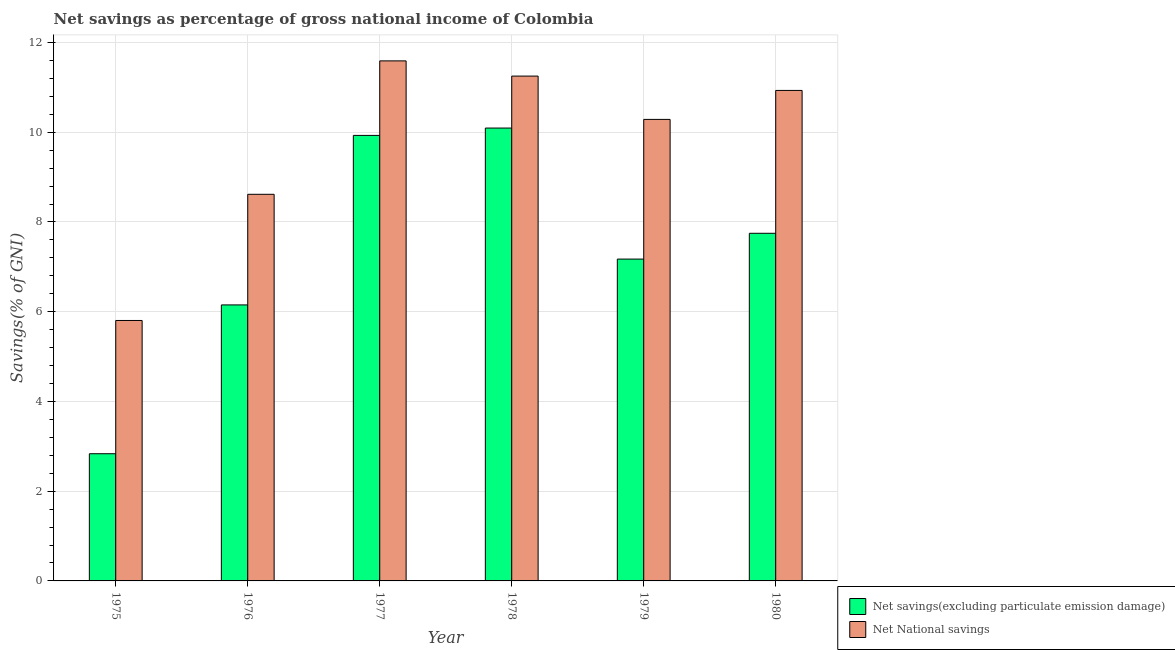How many groups of bars are there?
Your answer should be compact. 6. Are the number of bars per tick equal to the number of legend labels?
Make the answer very short. Yes. What is the label of the 6th group of bars from the left?
Keep it short and to the point. 1980. What is the net national savings in 1977?
Your answer should be compact. 11.59. Across all years, what is the maximum net national savings?
Your answer should be very brief. 11.59. Across all years, what is the minimum net national savings?
Provide a short and direct response. 5.8. In which year was the net savings(excluding particulate emission damage) maximum?
Provide a succinct answer. 1978. In which year was the net savings(excluding particulate emission damage) minimum?
Make the answer very short. 1975. What is the total net savings(excluding particulate emission damage) in the graph?
Keep it short and to the point. 43.93. What is the difference between the net national savings in 1976 and that in 1977?
Keep it short and to the point. -2.97. What is the difference between the net savings(excluding particulate emission damage) in 1980 and the net national savings in 1977?
Your answer should be compact. -2.18. What is the average net national savings per year?
Give a very brief answer. 9.75. In how many years, is the net savings(excluding particulate emission damage) greater than 9.2 %?
Keep it short and to the point. 2. What is the ratio of the net savings(excluding particulate emission damage) in 1975 to that in 1977?
Keep it short and to the point. 0.29. Is the net savings(excluding particulate emission damage) in 1975 less than that in 1978?
Your answer should be very brief. Yes. Is the difference between the net national savings in 1977 and 1980 greater than the difference between the net savings(excluding particulate emission damage) in 1977 and 1980?
Your answer should be compact. No. What is the difference between the highest and the second highest net savings(excluding particulate emission damage)?
Ensure brevity in your answer.  0.16. What is the difference between the highest and the lowest net national savings?
Offer a terse response. 5.79. In how many years, is the net savings(excluding particulate emission damage) greater than the average net savings(excluding particulate emission damage) taken over all years?
Provide a succinct answer. 3. What does the 1st bar from the left in 1976 represents?
Provide a short and direct response. Net savings(excluding particulate emission damage). What does the 2nd bar from the right in 1979 represents?
Offer a terse response. Net savings(excluding particulate emission damage). What is the difference between two consecutive major ticks on the Y-axis?
Offer a terse response. 2. How many legend labels are there?
Provide a short and direct response. 2. What is the title of the graph?
Your response must be concise. Net savings as percentage of gross national income of Colombia. What is the label or title of the X-axis?
Ensure brevity in your answer.  Year. What is the label or title of the Y-axis?
Make the answer very short. Savings(% of GNI). What is the Savings(% of GNI) in Net savings(excluding particulate emission damage) in 1975?
Ensure brevity in your answer.  2.84. What is the Savings(% of GNI) of Net National savings in 1975?
Provide a succinct answer. 5.8. What is the Savings(% of GNI) of Net savings(excluding particulate emission damage) in 1976?
Keep it short and to the point. 6.15. What is the Savings(% of GNI) of Net National savings in 1976?
Provide a succinct answer. 8.62. What is the Savings(% of GNI) in Net savings(excluding particulate emission damage) in 1977?
Your response must be concise. 9.93. What is the Savings(% of GNI) of Net National savings in 1977?
Provide a succinct answer. 11.59. What is the Savings(% of GNI) of Net savings(excluding particulate emission damage) in 1978?
Provide a short and direct response. 10.09. What is the Savings(% of GNI) of Net National savings in 1978?
Your answer should be compact. 11.25. What is the Savings(% of GNI) of Net savings(excluding particulate emission damage) in 1979?
Provide a succinct answer. 7.17. What is the Savings(% of GNI) in Net National savings in 1979?
Your answer should be compact. 10.29. What is the Savings(% of GNI) in Net savings(excluding particulate emission damage) in 1980?
Offer a very short reply. 7.75. What is the Savings(% of GNI) in Net National savings in 1980?
Your answer should be very brief. 10.93. Across all years, what is the maximum Savings(% of GNI) of Net savings(excluding particulate emission damage)?
Your response must be concise. 10.09. Across all years, what is the maximum Savings(% of GNI) in Net National savings?
Make the answer very short. 11.59. Across all years, what is the minimum Savings(% of GNI) in Net savings(excluding particulate emission damage)?
Offer a terse response. 2.84. Across all years, what is the minimum Savings(% of GNI) of Net National savings?
Your response must be concise. 5.8. What is the total Savings(% of GNI) of Net savings(excluding particulate emission damage) in the graph?
Make the answer very short. 43.93. What is the total Savings(% of GNI) in Net National savings in the graph?
Ensure brevity in your answer.  58.48. What is the difference between the Savings(% of GNI) of Net savings(excluding particulate emission damage) in 1975 and that in 1976?
Make the answer very short. -3.32. What is the difference between the Savings(% of GNI) of Net National savings in 1975 and that in 1976?
Ensure brevity in your answer.  -2.81. What is the difference between the Savings(% of GNI) in Net savings(excluding particulate emission damage) in 1975 and that in 1977?
Provide a short and direct response. -7.09. What is the difference between the Savings(% of GNI) of Net National savings in 1975 and that in 1977?
Keep it short and to the point. -5.79. What is the difference between the Savings(% of GNI) in Net savings(excluding particulate emission damage) in 1975 and that in 1978?
Offer a very short reply. -7.26. What is the difference between the Savings(% of GNI) in Net National savings in 1975 and that in 1978?
Provide a short and direct response. -5.45. What is the difference between the Savings(% of GNI) in Net savings(excluding particulate emission damage) in 1975 and that in 1979?
Provide a short and direct response. -4.34. What is the difference between the Savings(% of GNI) in Net National savings in 1975 and that in 1979?
Offer a very short reply. -4.48. What is the difference between the Savings(% of GNI) of Net savings(excluding particulate emission damage) in 1975 and that in 1980?
Offer a terse response. -4.91. What is the difference between the Savings(% of GNI) in Net National savings in 1975 and that in 1980?
Offer a very short reply. -5.13. What is the difference between the Savings(% of GNI) in Net savings(excluding particulate emission damage) in 1976 and that in 1977?
Offer a very short reply. -3.78. What is the difference between the Savings(% of GNI) in Net National savings in 1976 and that in 1977?
Your answer should be very brief. -2.97. What is the difference between the Savings(% of GNI) of Net savings(excluding particulate emission damage) in 1976 and that in 1978?
Provide a succinct answer. -3.94. What is the difference between the Savings(% of GNI) of Net National savings in 1976 and that in 1978?
Your answer should be compact. -2.63. What is the difference between the Savings(% of GNI) in Net savings(excluding particulate emission damage) in 1976 and that in 1979?
Ensure brevity in your answer.  -1.02. What is the difference between the Savings(% of GNI) in Net National savings in 1976 and that in 1979?
Make the answer very short. -1.67. What is the difference between the Savings(% of GNI) of Net savings(excluding particulate emission damage) in 1976 and that in 1980?
Offer a very short reply. -1.6. What is the difference between the Savings(% of GNI) of Net National savings in 1976 and that in 1980?
Your answer should be compact. -2.31. What is the difference between the Savings(% of GNI) of Net savings(excluding particulate emission damage) in 1977 and that in 1978?
Offer a terse response. -0.16. What is the difference between the Savings(% of GNI) of Net National savings in 1977 and that in 1978?
Your response must be concise. 0.34. What is the difference between the Savings(% of GNI) in Net savings(excluding particulate emission damage) in 1977 and that in 1979?
Provide a short and direct response. 2.76. What is the difference between the Savings(% of GNI) in Net National savings in 1977 and that in 1979?
Offer a terse response. 1.3. What is the difference between the Savings(% of GNI) in Net savings(excluding particulate emission damage) in 1977 and that in 1980?
Your answer should be very brief. 2.18. What is the difference between the Savings(% of GNI) in Net National savings in 1977 and that in 1980?
Provide a short and direct response. 0.66. What is the difference between the Savings(% of GNI) in Net savings(excluding particulate emission damage) in 1978 and that in 1979?
Your answer should be compact. 2.92. What is the difference between the Savings(% of GNI) of Net National savings in 1978 and that in 1979?
Make the answer very short. 0.97. What is the difference between the Savings(% of GNI) of Net savings(excluding particulate emission damage) in 1978 and that in 1980?
Make the answer very short. 2.35. What is the difference between the Savings(% of GNI) in Net National savings in 1978 and that in 1980?
Ensure brevity in your answer.  0.32. What is the difference between the Savings(% of GNI) of Net savings(excluding particulate emission damage) in 1979 and that in 1980?
Your answer should be compact. -0.57. What is the difference between the Savings(% of GNI) of Net National savings in 1979 and that in 1980?
Offer a terse response. -0.65. What is the difference between the Savings(% of GNI) of Net savings(excluding particulate emission damage) in 1975 and the Savings(% of GNI) of Net National savings in 1976?
Offer a terse response. -5.78. What is the difference between the Savings(% of GNI) of Net savings(excluding particulate emission damage) in 1975 and the Savings(% of GNI) of Net National savings in 1977?
Your response must be concise. -8.76. What is the difference between the Savings(% of GNI) of Net savings(excluding particulate emission damage) in 1975 and the Savings(% of GNI) of Net National savings in 1978?
Offer a terse response. -8.42. What is the difference between the Savings(% of GNI) of Net savings(excluding particulate emission damage) in 1975 and the Savings(% of GNI) of Net National savings in 1979?
Keep it short and to the point. -7.45. What is the difference between the Savings(% of GNI) in Net savings(excluding particulate emission damage) in 1975 and the Savings(% of GNI) in Net National savings in 1980?
Ensure brevity in your answer.  -8.1. What is the difference between the Savings(% of GNI) in Net savings(excluding particulate emission damage) in 1976 and the Savings(% of GNI) in Net National savings in 1977?
Ensure brevity in your answer.  -5.44. What is the difference between the Savings(% of GNI) of Net savings(excluding particulate emission damage) in 1976 and the Savings(% of GNI) of Net National savings in 1978?
Make the answer very short. -5.1. What is the difference between the Savings(% of GNI) in Net savings(excluding particulate emission damage) in 1976 and the Savings(% of GNI) in Net National savings in 1979?
Provide a succinct answer. -4.13. What is the difference between the Savings(% of GNI) of Net savings(excluding particulate emission damage) in 1976 and the Savings(% of GNI) of Net National savings in 1980?
Ensure brevity in your answer.  -4.78. What is the difference between the Savings(% of GNI) in Net savings(excluding particulate emission damage) in 1977 and the Savings(% of GNI) in Net National savings in 1978?
Offer a very short reply. -1.32. What is the difference between the Savings(% of GNI) of Net savings(excluding particulate emission damage) in 1977 and the Savings(% of GNI) of Net National savings in 1979?
Offer a terse response. -0.36. What is the difference between the Savings(% of GNI) of Net savings(excluding particulate emission damage) in 1977 and the Savings(% of GNI) of Net National savings in 1980?
Your answer should be compact. -1. What is the difference between the Savings(% of GNI) of Net savings(excluding particulate emission damage) in 1978 and the Savings(% of GNI) of Net National savings in 1979?
Provide a succinct answer. -0.19. What is the difference between the Savings(% of GNI) of Net savings(excluding particulate emission damage) in 1978 and the Savings(% of GNI) of Net National savings in 1980?
Make the answer very short. -0.84. What is the difference between the Savings(% of GNI) in Net savings(excluding particulate emission damage) in 1979 and the Savings(% of GNI) in Net National savings in 1980?
Your response must be concise. -3.76. What is the average Savings(% of GNI) of Net savings(excluding particulate emission damage) per year?
Ensure brevity in your answer.  7.32. What is the average Savings(% of GNI) in Net National savings per year?
Give a very brief answer. 9.75. In the year 1975, what is the difference between the Savings(% of GNI) in Net savings(excluding particulate emission damage) and Savings(% of GNI) in Net National savings?
Provide a short and direct response. -2.97. In the year 1976, what is the difference between the Savings(% of GNI) in Net savings(excluding particulate emission damage) and Savings(% of GNI) in Net National savings?
Keep it short and to the point. -2.47. In the year 1977, what is the difference between the Savings(% of GNI) in Net savings(excluding particulate emission damage) and Savings(% of GNI) in Net National savings?
Offer a very short reply. -1.66. In the year 1978, what is the difference between the Savings(% of GNI) in Net savings(excluding particulate emission damage) and Savings(% of GNI) in Net National savings?
Your response must be concise. -1.16. In the year 1979, what is the difference between the Savings(% of GNI) of Net savings(excluding particulate emission damage) and Savings(% of GNI) of Net National savings?
Offer a terse response. -3.11. In the year 1980, what is the difference between the Savings(% of GNI) of Net savings(excluding particulate emission damage) and Savings(% of GNI) of Net National savings?
Keep it short and to the point. -3.18. What is the ratio of the Savings(% of GNI) in Net savings(excluding particulate emission damage) in 1975 to that in 1976?
Your answer should be very brief. 0.46. What is the ratio of the Savings(% of GNI) of Net National savings in 1975 to that in 1976?
Your response must be concise. 0.67. What is the ratio of the Savings(% of GNI) of Net savings(excluding particulate emission damage) in 1975 to that in 1977?
Offer a terse response. 0.29. What is the ratio of the Savings(% of GNI) of Net National savings in 1975 to that in 1977?
Your answer should be compact. 0.5. What is the ratio of the Savings(% of GNI) in Net savings(excluding particulate emission damage) in 1975 to that in 1978?
Your answer should be very brief. 0.28. What is the ratio of the Savings(% of GNI) in Net National savings in 1975 to that in 1978?
Provide a short and direct response. 0.52. What is the ratio of the Savings(% of GNI) of Net savings(excluding particulate emission damage) in 1975 to that in 1979?
Offer a terse response. 0.4. What is the ratio of the Savings(% of GNI) of Net National savings in 1975 to that in 1979?
Provide a short and direct response. 0.56. What is the ratio of the Savings(% of GNI) in Net savings(excluding particulate emission damage) in 1975 to that in 1980?
Provide a succinct answer. 0.37. What is the ratio of the Savings(% of GNI) in Net National savings in 1975 to that in 1980?
Your response must be concise. 0.53. What is the ratio of the Savings(% of GNI) in Net savings(excluding particulate emission damage) in 1976 to that in 1977?
Keep it short and to the point. 0.62. What is the ratio of the Savings(% of GNI) in Net National savings in 1976 to that in 1977?
Your answer should be very brief. 0.74. What is the ratio of the Savings(% of GNI) in Net savings(excluding particulate emission damage) in 1976 to that in 1978?
Provide a succinct answer. 0.61. What is the ratio of the Savings(% of GNI) in Net National savings in 1976 to that in 1978?
Offer a terse response. 0.77. What is the ratio of the Savings(% of GNI) in Net savings(excluding particulate emission damage) in 1976 to that in 1979?
Offer a terse response. 0.86. What is the ratio of the Savings(% of GNI) of Net National savings in 1976 to that in 1979?
Ensure brevity in your answer.  0.84. What is the ratio of the Savings(% of GNI) of Net savings(excluding particulate emission damage) in 1976 to that in 1980?
Give a very brief answer. 0.79. What is the ratio of the Savings(% of GNI) of Net National savings in 1976 to that in 1980?
Offer a terse response. 0.79. What is the ratio of the Savings(% of GNI) of Net savings(excluding particulate emission damage) in 1977 to that in 1978?
Your answer should be very brief. 0.98. What is the ratio of the Savings(% of GNI) of Net National savings in 1977 to that in 1978?
Your answer should be very brief. 1.03. What is the ratio of the Savings(% of GNI) of Net savings(excluding particulate emission damage) in 1977 to that in 1979?
Your answer should be very brief. 1.38. What is the ratio of the Savings(% of GNI) of Net National savings in 1977 to that in 1979?
Your answer should be very brief. 1.13. What is the ratio of the Savings(% of GNI) in Net savings(excluding particulate emission damage) in 1977 to that in 1980?
Ensure brevity in your answer.  1.28. What is the ratio of the Savings(% of GNI) in Net National savings in 1977 to that in 1980?
Your answer should be very brief. 1.06. What is the ratio of the Savings(% of GNI) in Net savings(excluding particulate emission damage) in 1978 to that in 1979?
Keep it short and to the point. 1.41. What is the ratio of the Savings(% of GNI) of Net National savings in 1978 to that in 1979?
Keep it short and to the point. 1.09. What is the ratio of the Savings(% of GNI) in Net savings(excluding particulate emission damage) in 1978 to that in 1980?
Your answer should be very brief. 1.3. What is the ratio of the Savings(% of GNI) in Net National savings in 1978 to that in 1980?
Provide a short and direct response. 1.03. What is the ratio of the Savings(% of GNI) in Net savings(excluding particulate emission damage) in 1979 to that in 1980?
Make the answer very short. 0.93. What is the ratio of the Savings(% of GNI) of Net National savings in 1979 to that in 1980?
Keep it short and to the point. 0.94. What is the difference between the highest and the second highest Savings(% of GNI) in Net savings(excluding particulate emission damage)?
Your answer should be compact. 0.16. What is the difference between the highest and the second highest Savings(% of GNI) of Net National savings?
Give a very brief answer. 0.34. What is the difference between the highest and the lowest Savings(% of GNI) in Net savings(excluding particulate emission damage)?
Provide a short and direct response. 7.26. What is the difference between the highest and the lowest Savings(% of GNI) of Net National savings?
Offer a very short reply. 5.79. 